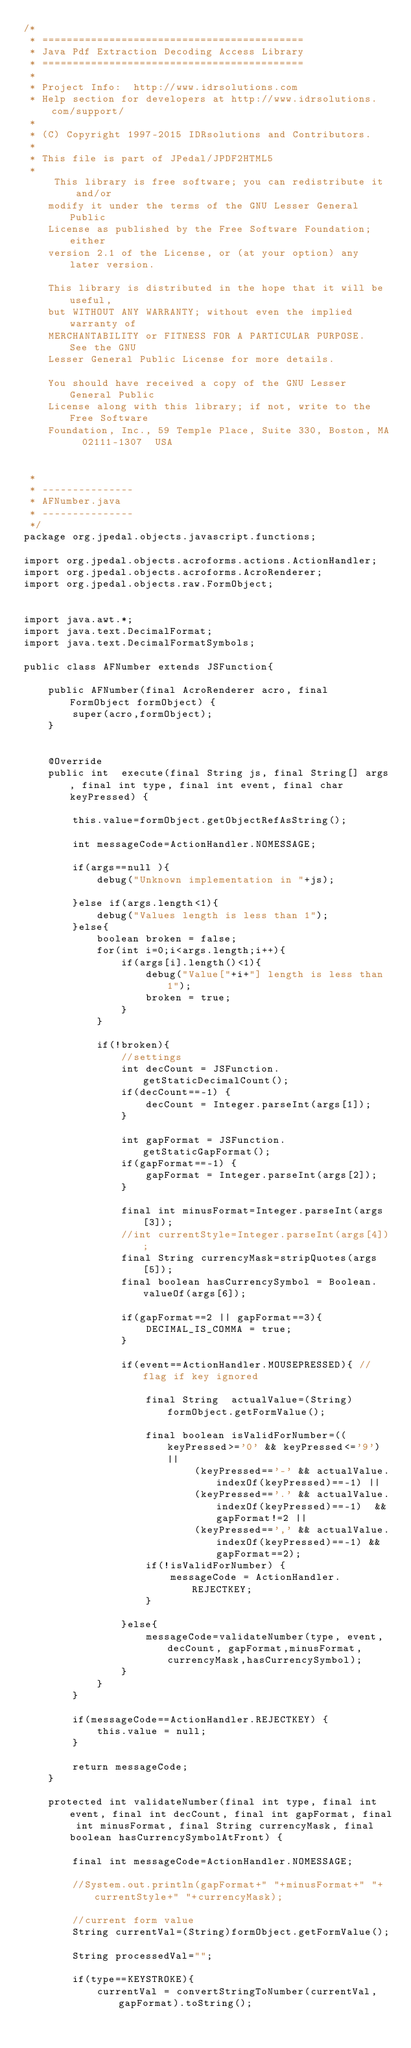Convert code to text. <code><loc_0><loc_0><loc_500><loc_500><_Java_>/*
 * ===========================================
 * Java Pdf Extraction Decoding Access Library
 * ===========================================
 *
 * Project Info:  http://www.idrsolutions.com
 * Help section for developers at http://www.idrsolutions.com/support/
 *
 * (C) Copyright 1997-2015 IDRsolutions and Contributors.
 *
 * This file is part of JPedal/JPDF2HTML5
 *
     This library is free software; you can redistribute it and/or
    modify it under the terms of the GNU Lesser General Public
    License as published by the Free Software Foundation; either
    version 2.1 of the License, or (at your option) any later version.

    This library is distributed in the hope that it will be useful,
    but WITHOUT ANY WARRANTY; without even the implied warranty of
    MERCHANTABILITY or FITNESS FOR A PARTICULAR PURPOSE.  See the GNU
    Lesser General Public License for more details.

    You should have received a copy of the GNU Lesser General Public
    License along with this library; if not, write to the Free Software
    Foundation, Inc., 59 Temple Place, Suite 330, Boston, MA  02111-1307  USA


 *
 * ---------------
 * AFNumber.java
 * ---------------
 */
package org.jpedal.objects.javascript.functions;

import org.jpedal.objects.acroforms.actions.ActionHandler;
import org.jpedal.objects.acroforms.AcroRenderer;
import org.jpedal.objects.raw.FormObject;


import java.awt.*;
import java.text.DecimalFormat;
import java.text.DecimalFormatSymbols;

public class AFNumber extends JSFunction{

	public AFNumber(final AcroRenderer acro, final FormObject formObject) {
		super(acro,formObject);
	}


	@Override
    public int  execute(final String js, final String[] args, final int type, final int event, final char keyPressed) {

		this.value=formObject.getObjectRefAsString();
		
		int messageCode=ActionHandler.NOMESSAGE;
		
		if(args==null ){
			debug("Unknown implementation in "+js);

		}else if(args.length<1){
			debug("Values length is less than 1");
		}else{
			boolean broken = false;
			for(int i=0;i<args.length;i++){
				if(args[i].length()<1){
					debug("Value["+i+"] length is less than 1");
					broken = true;
				}
			}
			
			if(!broken){
				//settings
				int decCount = JSFunction.getStaticDecimalCount();
				if(decCount==-1) {
                    decCount = Integer.parseInt(args[1]);
                }
				
				int gapFormat = JSFunction.getStaticGapFormat();
				if(gapFormat==-1) {
                    gapFormat = Integer.parseInt(args[2]);
                }
				
				final int minusFormat=Integer.parseInt(args[3]);
				//int currentStyle=Integer.parseInt(args[4]);
				final String currencyMask=stripQuotes(args[5]);
				final boolean hasCurrencySymbol = Boolean.valueOf(args[6]);
	
				if(gapFormat==2 || gapFormat==3){
					DECIMAL_IS_COMMA = true;
				}
	
				if(event==ActionHandler.MOUSEPRESSED){ //flag if key ignored
					
					final String  actualValue=(String) formObject.getFormValue();

					final boolean isValidForNumber=((keyPressed>='0' && keyPressed<='9') ||
							(keyPressed=='-' && actualValue.indexOf(keyPressed)==-1) || 
							(keyPressed=='.' && actualValue.indexOf(keyPressed)==-1)  && gapFormat!=2 || 
							(keyPressed==',' && actualValue.indexOf(keyPressed)==-1) && gapFormat==2);
					if(!isValidForNumber) {
                        messageCode = ActionHandler.REJECTKEY;
                    }
	
				}else{
					messageCode=validateNumber(type, event, decCount, gapFormat,minusFormat, currencyMask,hasCurrencySymbol);
				}
			}
		}
		
		if(messageCode==ActionHandler.REJECTKEY) {
            this.value = null;
        }

		return messageCode;
	}

	protected int validateNumber(final int type, final int event, final int decCount, final int gapFormat, final int minusFormat, final String currencyMask, final boolean hasCurrencySymbolAtFront) {

		final int messageCode=ActionHandler.NOMESSAGE;

		//System.out.println(gapFormat+" "+minusFormat+" "+currentStyle+" "+currencyMask);

		//current form value
		String currentVal=(String)formObject.getFormValue();

		String processedVal="";

		if(type==KEYSTROKE){
			currentVal = convertStringToNumber(currentVal,gapFormat).toString();
			</code> 